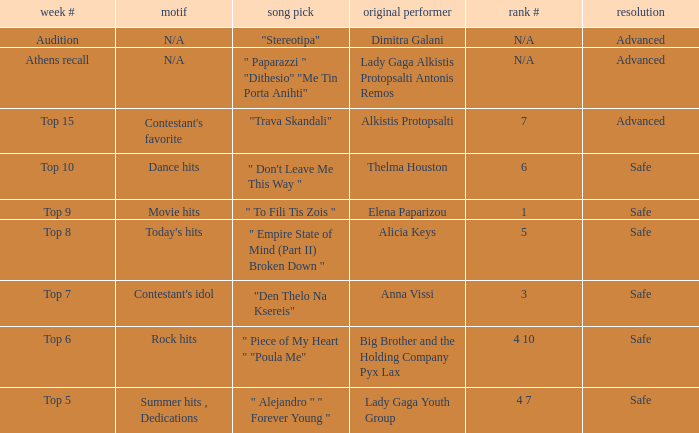Which artists have order number 6? Thelma Houston. 